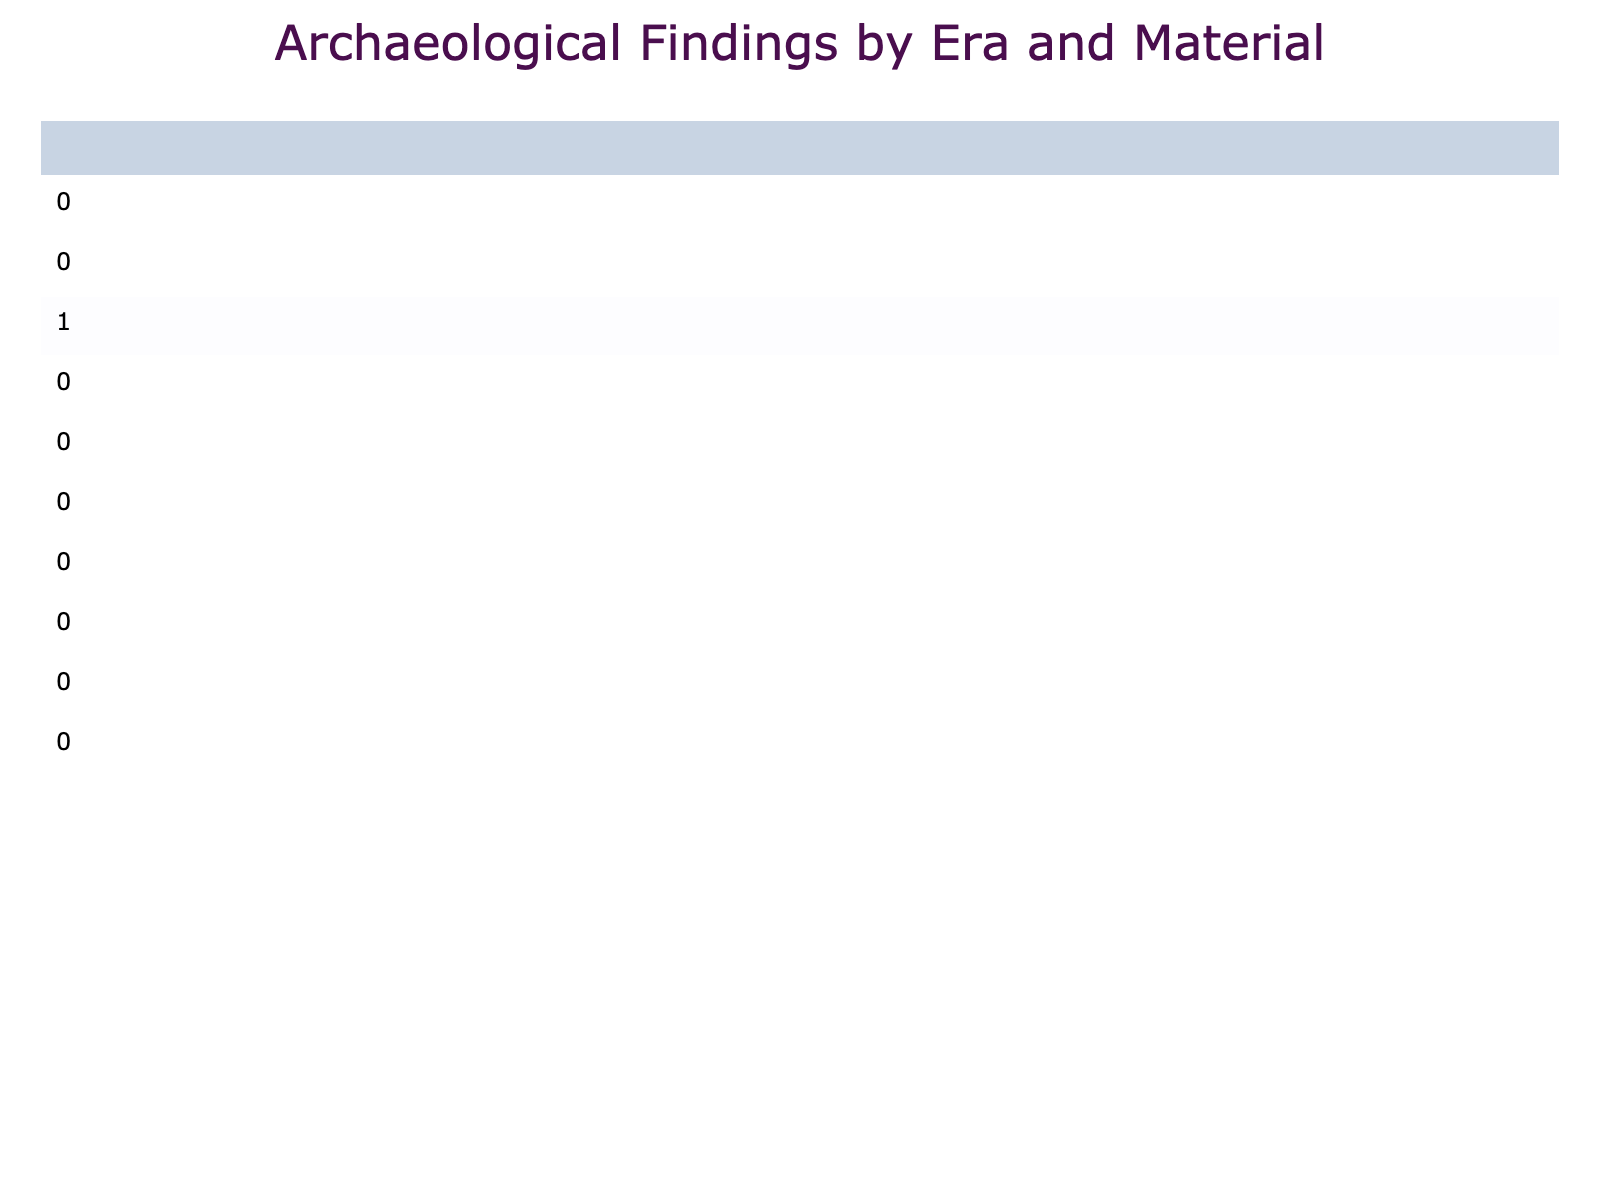What is the total quantity of artifacts found from the Viking era? There are two entries for the Viking era: 1 Norse Sword Hilt and 1 Whalebone Plaque. Adding these quantities together gives us a total of 1 + 1 = 2 artifacts.
Answer: 2 Which era has the highest quantity of metal artifacts? Looking at the Metal column in the table, the Bronze Age has a total of 3 (Bronze Axe Head) + 2 (Antler Comb) = 5, the Iron Age has 1 (Iron Sword) + 15 (Colored Glass Bead, which doesn't count as metal) = 1, the Roman era has 22 (Denarius Coin), the Pictish era has 2 (Silver Brooch), and the Jacobite era has 30 (Lead Musket Ball). Adding up gives Roman (22) + Jacobite (30) = 52 with the highest quantity.
Answer: Roman How many artifacts were found in Edinburgh Castle? The entry for Edinburgh Castle lists 7 Silver Groat Coins under the Medieval era.
Answer: 7 Is there a certain era with no artifacts made of stone? Reviewing the table, both the Roman and Jacobite eras show no entries for stone artifacts. Thus, they can be determined as the eras with no stone findings.
Answer: Yes What is the total quantity of artifacts found in the Neolithic and Bronze Age combined? The Neolithic includes 12 (Flint Arrowhead) + 8 (Grooved Ware Fragment) = 20, while the Bronze Age includes 3 (Bronze Axe Head) + 2 (Antler Comb) = 5. Adding both totals gives us 20 + 5 = 25 artifacts.
Answer: 25 Which material has the highest quantity in the table? Assessing all quantities, we see that Metal has 52 (22 Roman + 30 Jacobite), Pottery has 24 (8 Neolithic + 4 Roman + 5 Medieval + 10 Victorian), Glass has 8 (15 Iron Age + 6 Victorian), Stone has 16 (12 Neolithic + 1 Pictish) plus others. Therefore, the highest total from material types displayed is Metal with 52.
Answer: Metal What is the average quantity of artifacts found in the Victorian era? In the Victorian era, there are two entries: 10 Blue and White Ceramic Plates and 6 Decorative Glass Bottles. Adding them gives 10 + 6 = 16 artifacts. Dividing that by the number of entries (2) gives an average of 16/2 = 8.
Answer: 8 